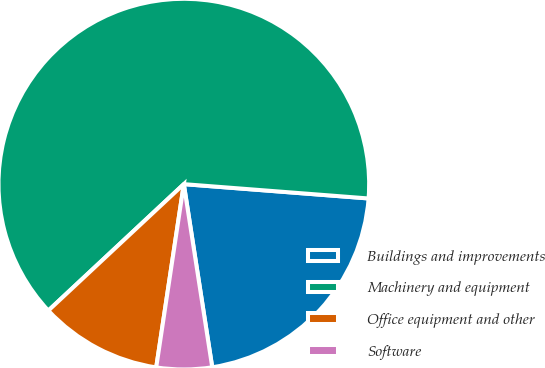<chart> <loc_0><loc_0><loc_500><loc_500><pie_chart><fcel>Buildings and improvements<fcel>Machinery and equipment<fcel>Office equipment and other<fcel>Software<nl><fcel>21.32%<fcel>63.19%<fcel>10.67%<fcel>4.83%<nl></chart> 